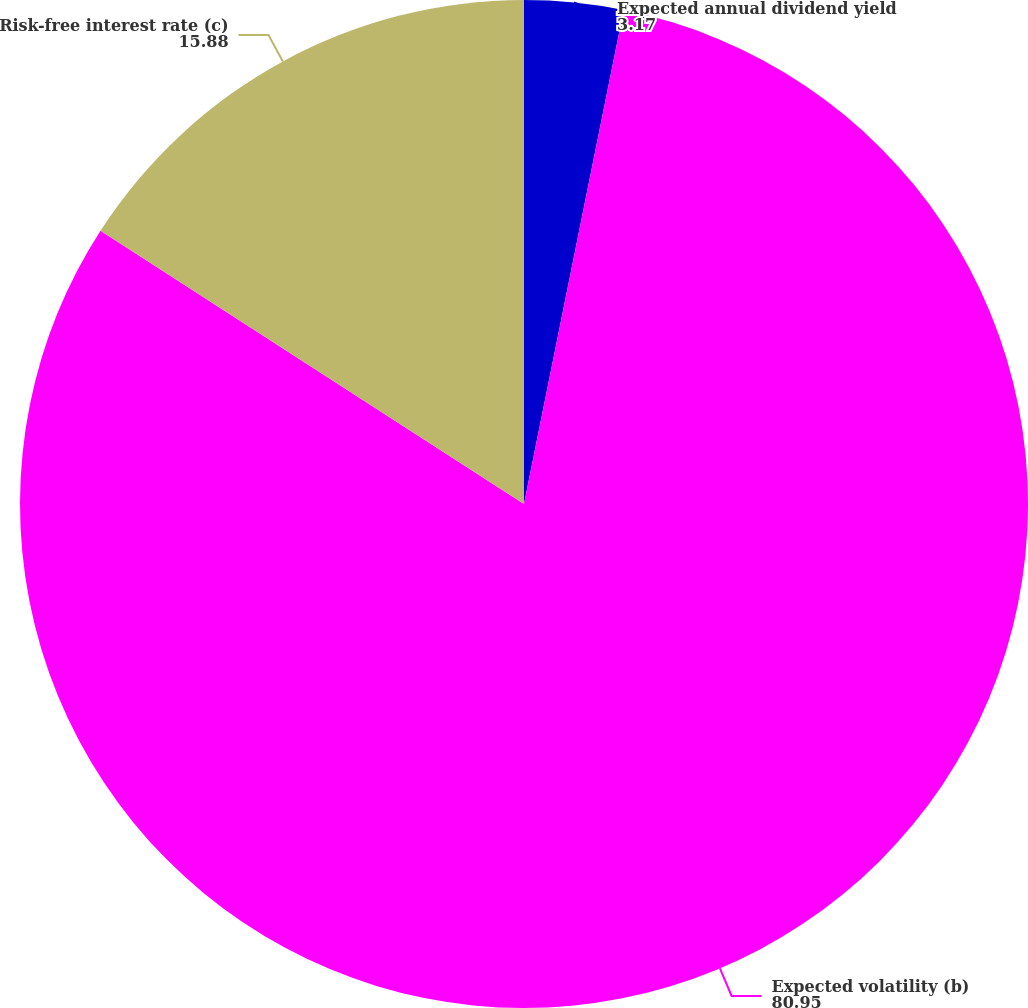<chart> <loc_0><loc_0><loc_500><loc_500><pie_chart><fcel>Expected annual dividend yield<fcel>Expected volatility (b)<fcel>Risk-free interest rate (c)<nl><fcel>3.17%<fcel>80.95%<fcel>15.88%<nl></chart> 